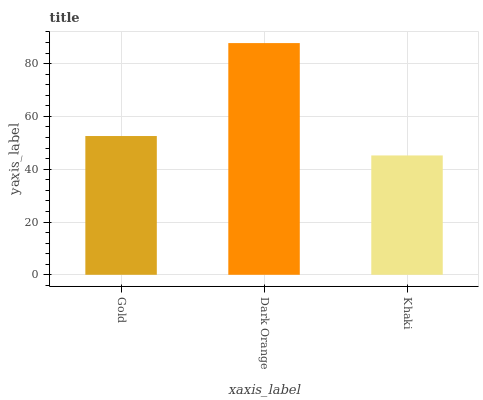Is Khaki the minimum?
Answer yes or no. Yes. Is Dark Orange the maximum?
Answer yes or no. Yes. Is Dark Orange the minimum?
Answer yes or no. No. Is Khaki the maximum?
Answer yes or no. No. Is Dark Orange greater than Khaki?
Answer yes or no. Yes. Is Khaki less than Dark Orange?
Answer yes or no. Yes. Is Khaki greater than Dark Orange?
Answer yes or no. No. Is Dark Orange less than Khaki?
Answer yes or no. No. Is Gold the high median?
Answer yes or no. Yes. Is Gold the low median?
Answer yes or no. Yes. Is Dark Orange the high median?
Answer yes or no. No. Is Dark Orange the low median?
Answer yes or no. No. 